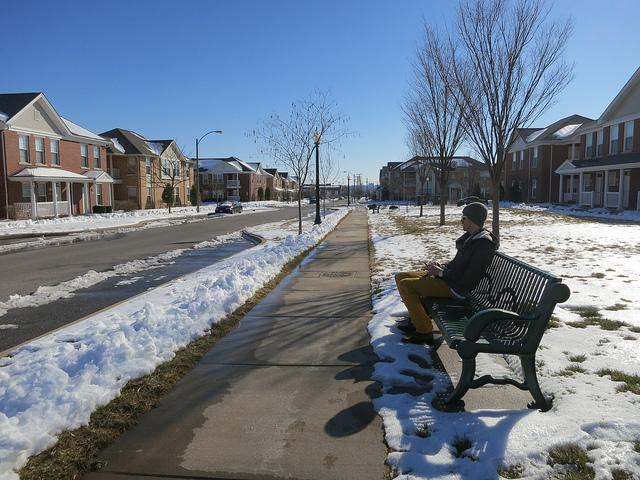In which area does the man wait?

Choices:
A) rural
B) forest
C) suburban
D) urban suburban 